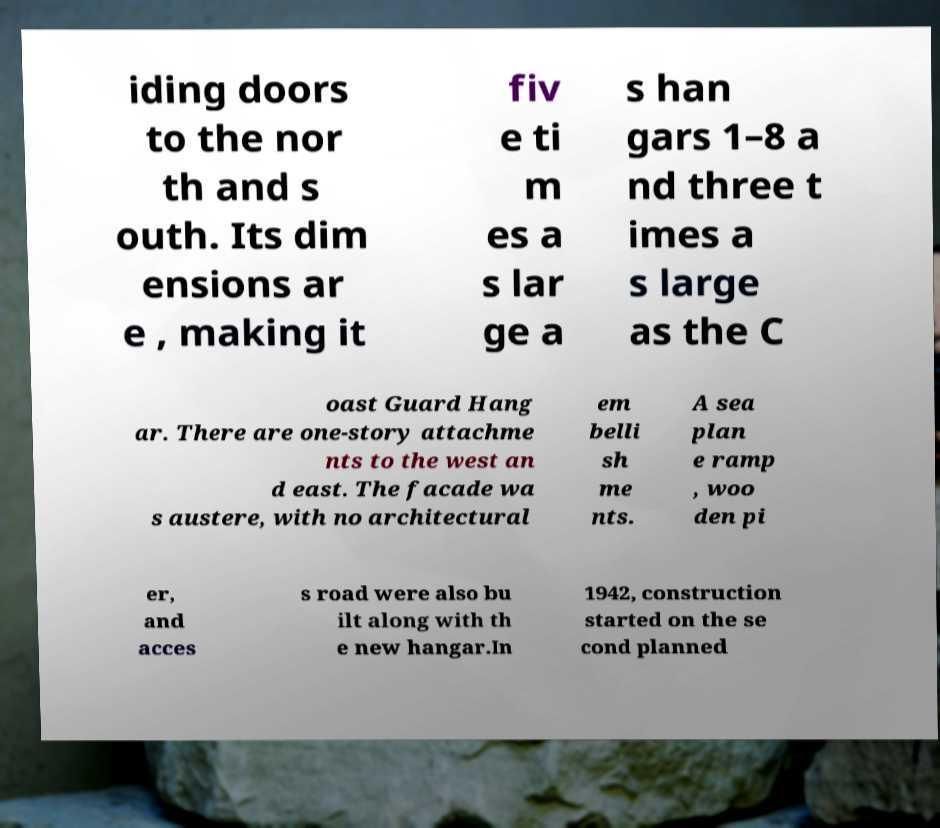Could you extract and type out the text from this image? iding doors to the nor th and s outh. Its dim ensions ar e , making it fiv e ti m es a s lar ge a s han gars 1–8 a nd three t imes a s large as the C oast Guard Hang ar. There are one-story attachme nts to the west an d east. The facade wa s austere, with no architectural em belli sh me nts. A sea plan e ramp , woo den pi er, and acces s road were also bu ilt along with th e new hangar.In 1942, construction started on the se cond planned 